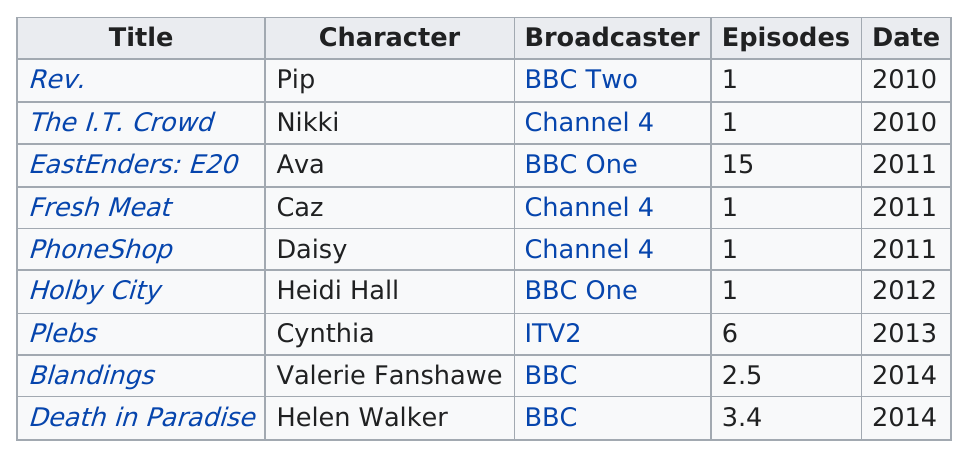Indicate a few pertinent items in this graphic. The only role that Cynthia played with broadcaster ITV2 is Cynthia. Channel 4 hosted three titles but had only one episode. There were more than four episodes that featured Cynthia. Yes, there were. Sophie Colquhoun appeared on only one show in 2012, and that show was "Holby City. The first character listed is 'Pip'. 